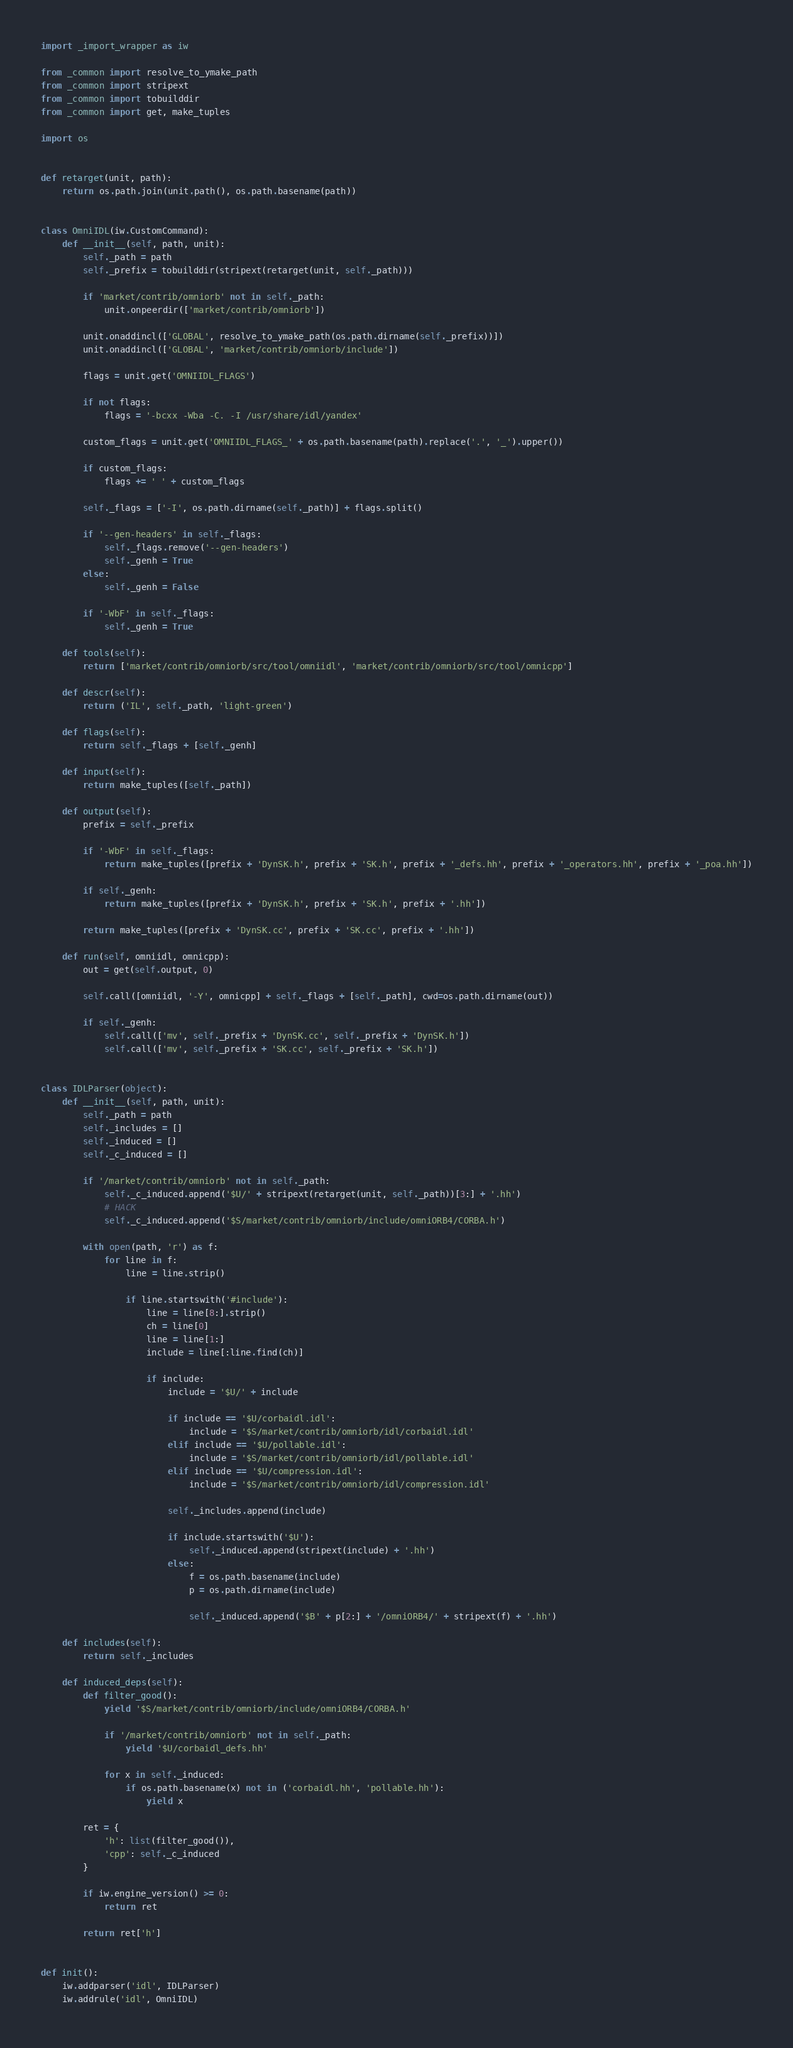Convert code to text. <code><loc_0><loc_0><loc_500><loc_500><_Python_>import _import_wrapper as iw

from _common import resolve_to_ymake_path
from _common import stripext
from _common import tobuilddir
from _common import get, make_tuples

import os


def retarget(unit, path):
    return os.path.join(unit.path(), os.path.basename(path))


class OmniIDL(iw.CustomCommand):
    def __init__(self, path, unit):
        self._path = path
        self._prefix = tobuilddir(stripext(retarget(unit, self._path)))

        if 'market/contrib/omniorb' not in self._path:
            unit.onpeerdir(['market/contrib/omniorb'])

        unit.onaddincl(['GLOBAL', resolve_to_ymake_path(os.path.dirname(self._prefix))])
        unit.onaddincl(['GLOBAL', 'market/contrib/omniorb/include'])

        flags = unit.get('OMNIIDL_FLAGS')

        if not flags:
            flags = '-bcxx -Wba -C. -I /usr/share/idl/yandex'

        custom_flags = unit.get('OMNIIDL_FLAGS_' + os.path.basename(path).replace('.', '_').upper())

        if custom_flags:
            flags += ' ' + custom_flags

        self._flags = ['-I', os.path.dirname(self._path)] + flags.split()

        if '--gen-headers' in self._flags:
            self._flags.remove('--gen-headers')
            self._genh = True
        else:
            self._genh = False

        if '-WbF' in self._flags:
            self._genh = True

    def tools(self):
        return ['market/contrib/omniorb/src/tool/omniidl', 'market/contrib/omniorb/src/tool/omnicpp']

    def descr(self):
        return ('IL', self._path, 'light-green')

    def flags(self):
        return self._flags + [self._genh]

    def input(self):
        return make_tuples([self._path])

    def output(self):
        prefix = self._prefix

        if '-WbF' in self._flags:
            return make_tuples([prefix + 'DynSK.h', prefix + 'SK.h', prefix + '_defs.hh', prefix + '_operators.hh', prefix + '_poa.hh'])

        if self._genh:
            return make_tuples([prefix + 'DynSK.h', prefix + 'SK.h', prefix + '.hh'])

        return make_tuples([prefix + 'DynSK.cc', prefix + 'SK.cc', prefix + '.hh'])

    def run(self, omniidl, omnicpp):
        out = get(self.output, 0)

        self.call([omniidl, '-Y', omnicpp] + self._flags + [self._path], cwd=os.path.dirname(out))

        if self._genh:
            self.call(['mv', self._prefix + 'DynSK.cc', self._prefix + 'DynSK.h'])
            self.call(['mv', self._prefix + 'SK.cc', self._prefix + 'SK.h'])


class IDLParser(object):
    def __init__(self, path, unit):
        self._path = path
        self._includes = []
        self._induced = []
        self._c_induced = []

        if '/market/contrib/omniorb' not in self._path:
            self._c_induced.append('$U/' + stripext(retarget(unit, self._path))[3:] + '.hh')
            # HACK
            self._c_induced.append('$S/market/contrib/omniorb/include/omniORB4/CORBA.h')

        with open(path, 'r') as f:
            for line in f:
                line = line.strip()

                if line.startswith('#include'):
                    line = line[8:].strip()
                    ch = line[0]
                    line = line[1:]
                    include = line[:line.find(ch)]

                    if include:
                        include = '$U/' + include

                        if include == '$U/corbaidl.idl':
                            include = '$S/market/contrib/omniorb/idl/corbaidl.idl'
                        elif include == '$U/pollable.idl':
                            include = '$S/market/contrib/omniorb/idl/pollable.idl'
                        elif include == '$U/compression.idl':
                            include = '$S/market/contrib/omniorb/idl/compression.idl'

                        self._includes.append(include)

                        if include.startswith('$U'):
                            self._induced.append(stripext(include) + '.hh')
                        else:
                            f = os.path.basename(include)
                            p = os.path.dirname(include)

                            self._induced.append('$B' + p[2:] + '/omniORB4/' + stripext(f) + '.hh')

    def includes(self):
        return self._includes

    def induced_deps(self):
        def filter_good():
            yield '$S/market/contrib/omniorb/include/omniORB4/CORBA.h'

            if '/market/contrib/omniorb' not in self._path:
                yield '$U/corbaidl_defs.hh'

            for x in self._induced:
                if os.path.basename(x) not in ('corbaidl.hh', 'pollable.hh'):
                    yield x

        ret = {
            'h': list(filter_good()),
            'cpp': self._c_induced
        }

        if iw.engine_version() >= 0:
            return ret

        return ret['h']


def init():
    iw.addparser('idl', IDLParser)
    iw.addrule('idl', OmniIDL)
</code> 